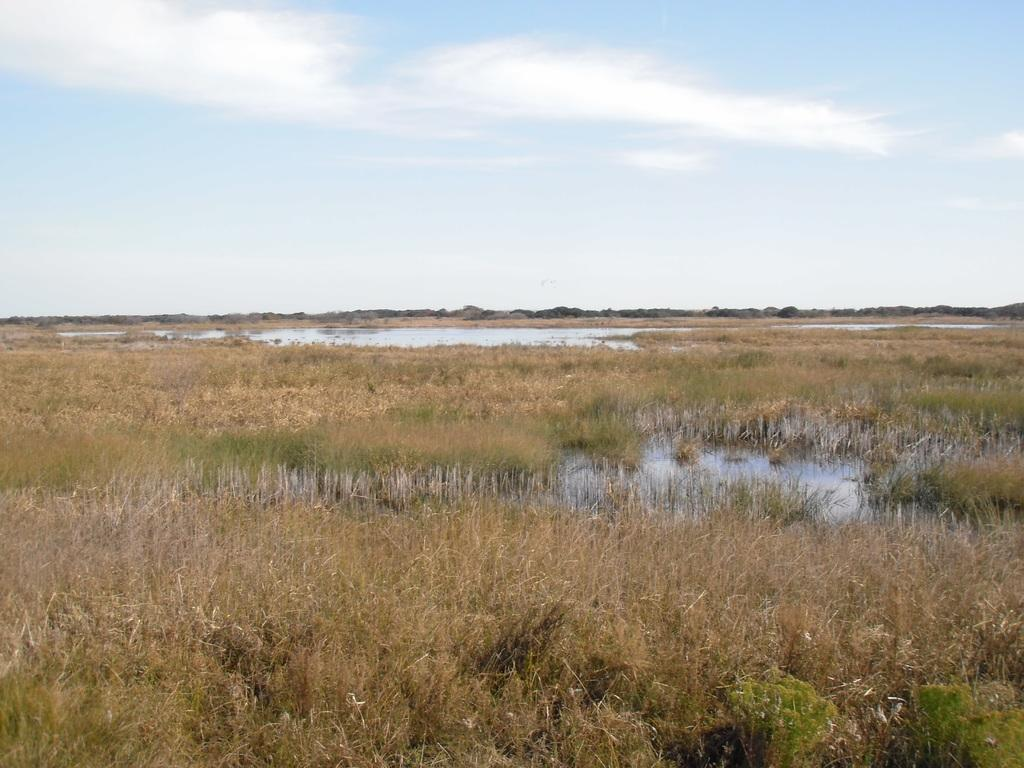What type of vegetation can be seen in the image? There is grass in the image. What else is present in the image besides grass? There is water in the image. What can be seen in the background of the image? There are clouds and the sky visible in the background of the image. Can you tell me where the stamp is located in the image? There is no stamp present in the image. What type of musical group can be seen performing in the image? There is no band present in the image. 